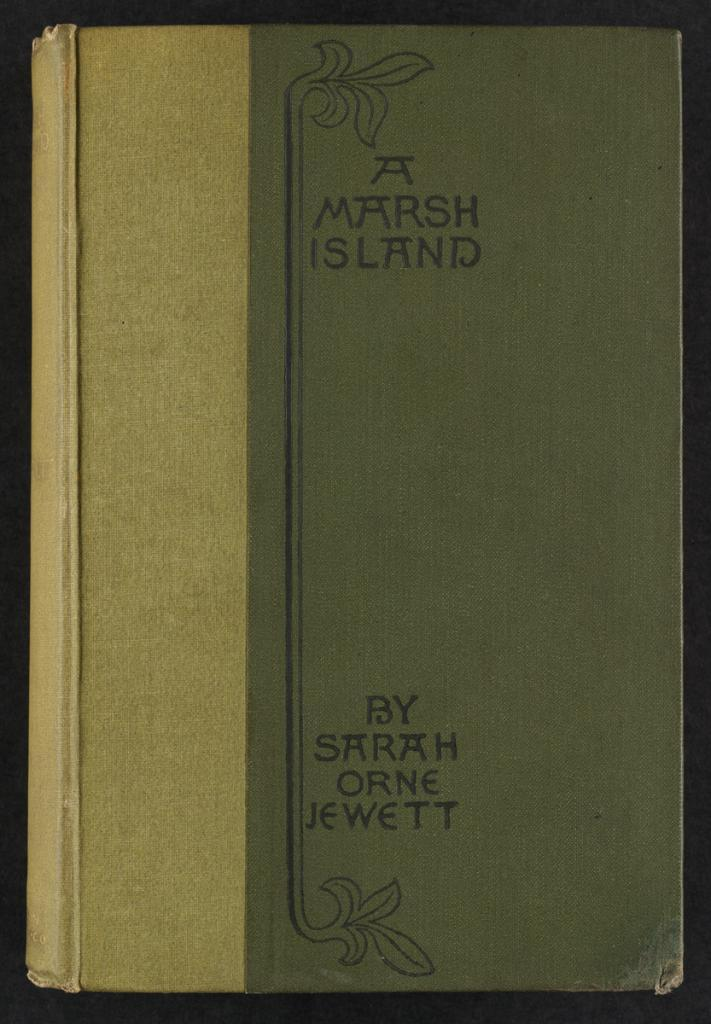Provide a one-sentence caption for the provided image. a book called a marsh island by sarah orne jewett. 